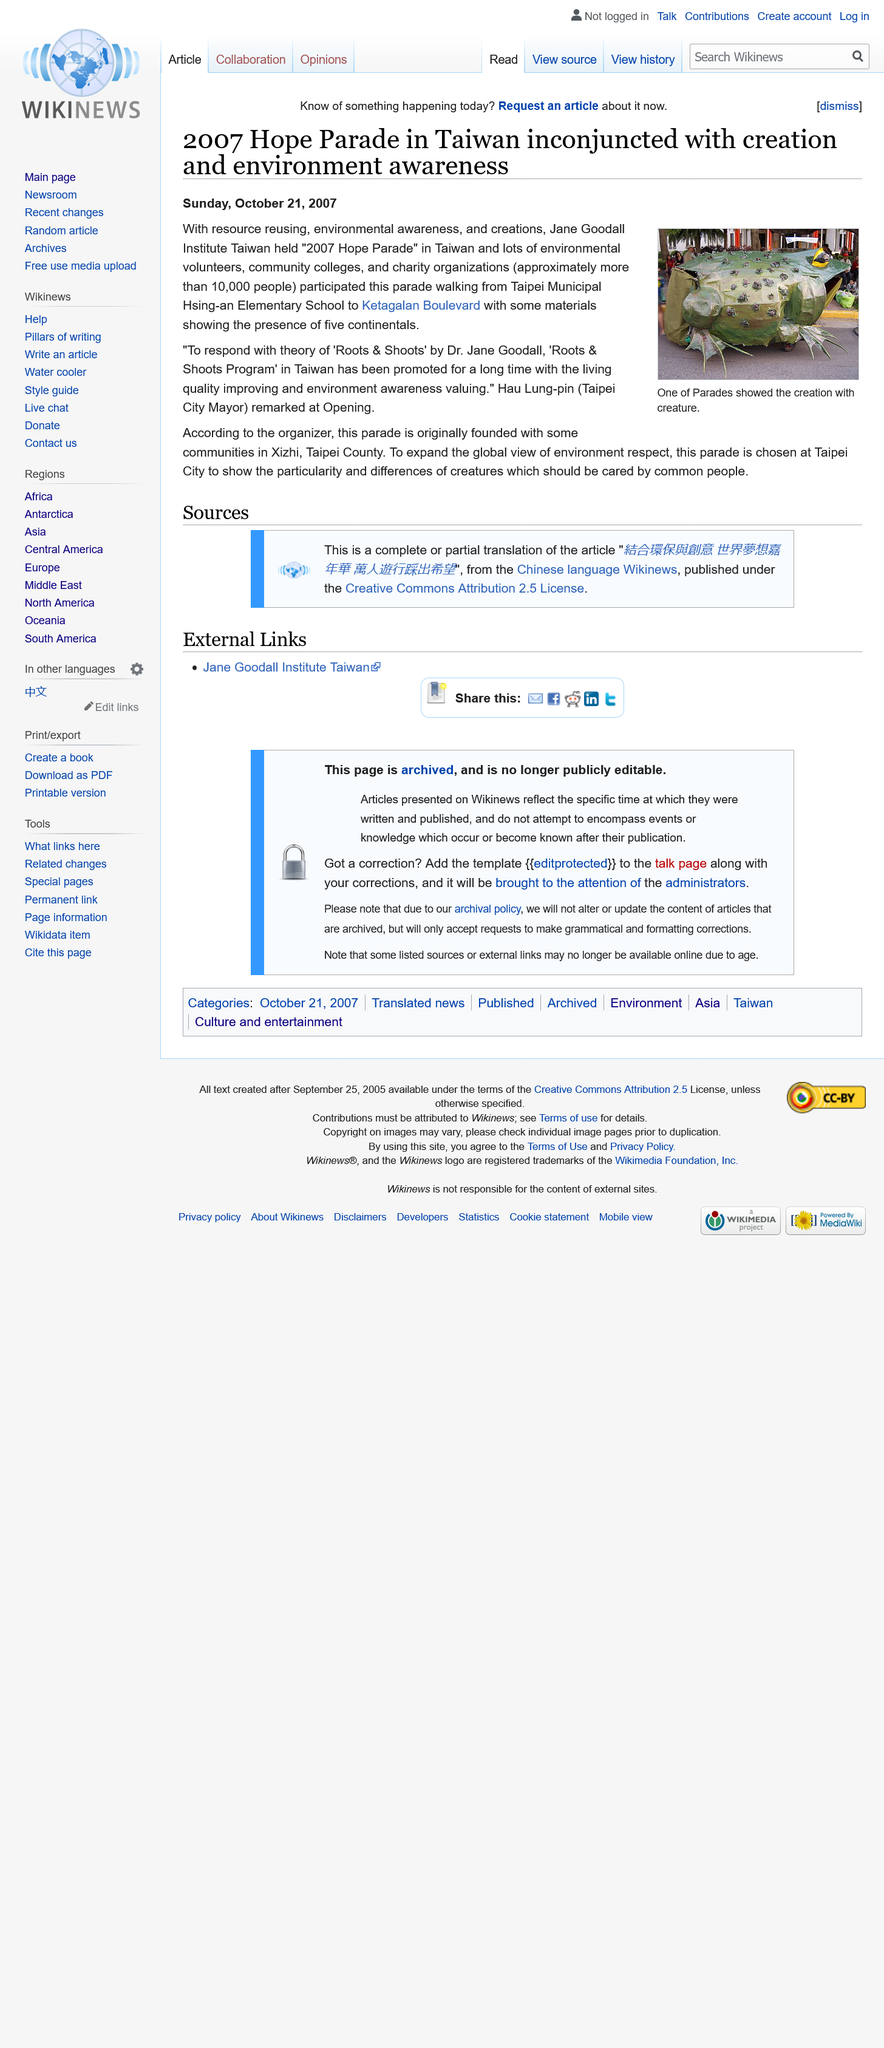Specify some key components in this picture. The article was published on October 21, 2007. One of the parade's creations depicted a creature that was identified as a frog. The parade was named "The Hope Parade. 